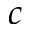<formula> <loc_0><loc_0><loc_500><loc_500>c</formula> 